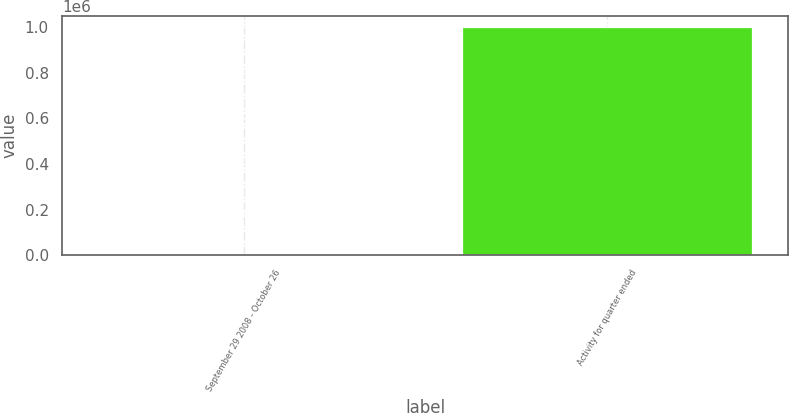<chart> <loc_0><loc_0><loc_500><loc_500><bar_chart><fcel>September 29 2008 - October 26<fcel>Activity for quarter ended<nl><fcel>4.41<fcel>1e+06<nl></chart> 